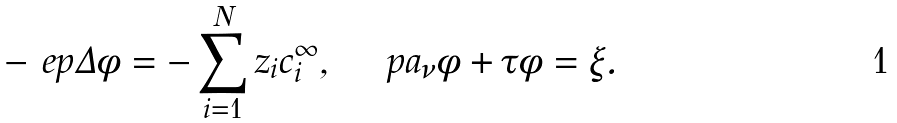Convert formula to latex. <formula><loc_0><loc_0><loc_500><loc_500>- \ e p \Delta \phi = - \sum _ { i = 1 } ^ { N } z _ { i } c _ { i } ^ { \infty } , \quad \ p a _ { \nu } \phi + \tau \phi = \xi .</formula> 